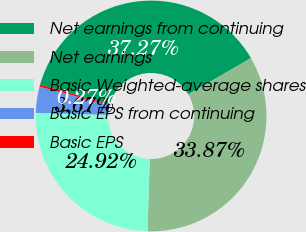Convert chart. <chart><loc_0><loc_0><loc_500><loc_500><pie_chart><fcel>Net earnings from continuing<fcel>Net earnings<fcel>Basic Weighted-average shares<fcel>Basic EPS from continuing<fcel>Basic EPS<nl><fcel>37.27%<fcel>33.87%<fcel>24.92%<fcel>3.67%<fcel>0.27%<nl></chart> 